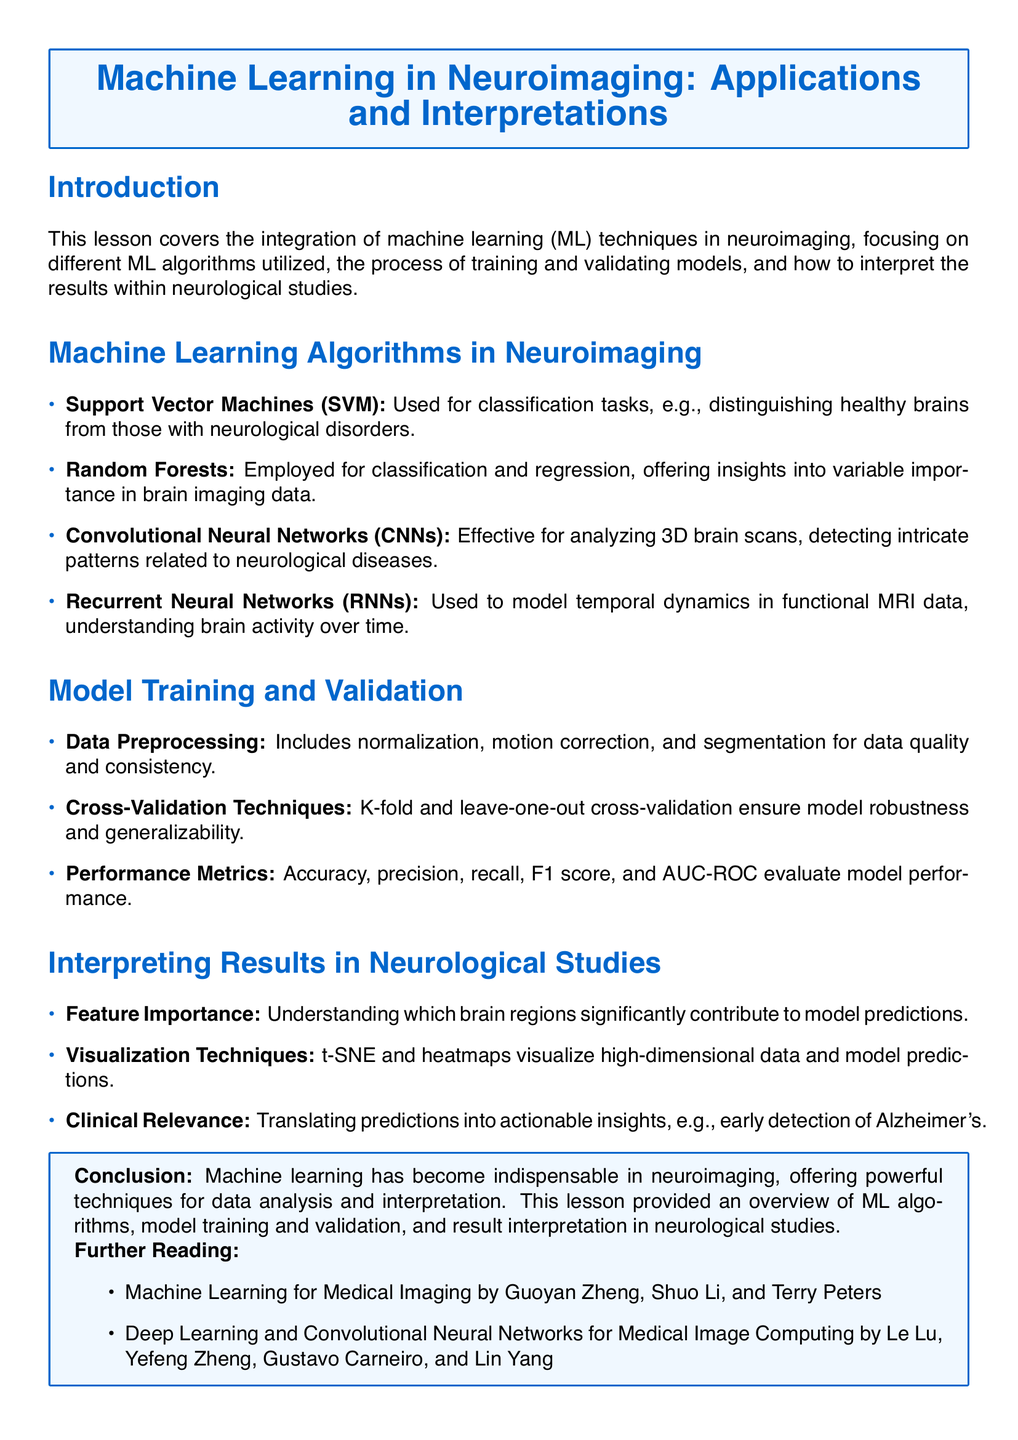What are the four machine learning algorithms mentioned in the document? The document lists Support Vector Machines, Random Forests, Convolutional Neural Networks, and Recurrent Neural Networks as the four machine learning algorithms used in neuroimaging.
Answer: Support Vector Machines, Random Forests, Convolutional Neural Networks, Recurrent Neural Networks What is the purpose of model validation in machine learning? Model validation ensures that the machine learning models are robust and generalizable, which is a critical aspect emphasized in the model training section of the document.
Answer: Robustness and generalizability What performance metrics are discussed in the lesson? The lesson covers accuracy, precision, recall, F1 score, and AUC-ROC as performance metrics for evaluating model performance in neuroimaging.
Answer: Accuracy, precision, recall, F1 score, AUC-ROC Which technique is used for visualizing high-dimensional data? The document mentions t-SNE and heatmaps as visualization techniques that help in visualizing high-dimensional data and model predictions.
Answer: t-SNE and heatmaps What is the clinical relevance of machine learning mentioned? The lesson highlights the importance of translating predictions into actionable insights, such as early detection of Alzheimer's, emphasizing the actionable aspect of machine learning predictions in clinical settings.
Answer: Early detection of Alzheimer's How does data preprocessing contribute to neuroimaging data? Data preprocessing is stated to include normalization, motion correction, and segmentation, which are vital for ensuring data quality and consistency.
Answer: Quality and consistency What is the primary focus of the document? The main focus of the document is the integration of machine learning techniques in neuroimaging, detailing algorithms, model training, validation, and result interpretation.
Answer: Integration of machine learning techniques in neuroimaging What further reading is suggested in the document? The document suggests two further readings: "Machine Learning for Medical Imaging" by Guoyan Zheng et al. and "Deep Learning and Convolutional Neural Networks for Medical Image Computing" by Le Lu et al.
Answer: Machine Learning for Medical Imaging, Deep Learning and Convolutional Neural Networks for Medical Image Computing 